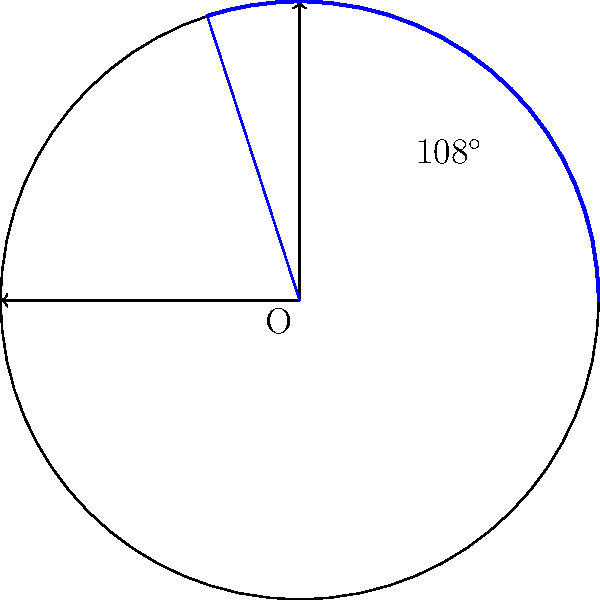A pie chart representing community health statistics has a sector with a central angle of 108°. If the radius of the chart is 15 cm, what is the area of this sector in square centimeters? Round your answer to two decimal places. To find the area of a sector in a circle, we can follow these steps:

1. Recall the formula for the area of a sector:
   $$ A = \frac{\theta}{360^\circ} \pi r^2 $$
   where $A$ is the area, $\theta$ is the central angle in degrees, and $r$ is the radius.

2. We are given:
   - Central angle $\theta = 108^\circ$
   - Radius $r = 15$ cm

3. Substitute these values into the formula:
   $$ A = \frac{108^\circ}{360^\circ} \pi (15 \text{ cm})^2 $$

4. Simplify:
   $$ A = \frac{3}{10} \pi (225 \text{ cm}^2) $$

5. Calculate:
   $$ A = 67.5\pi \text{ cm}^2 $$
   $$ A \approx 212.06 \text{ cm}^2 $$

6. Round to two decimal places:
   $$ A \approx 212.06 \text{ cm}^2 $$

This area represents the portion of the community health statistics corresponding to the 108° sector in the pie chart.
Answer: 212.06 cm² 